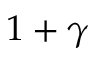Convert formula to latex. <formula><loc_0><loc_0><loc_500><loc_500>1 + \gamma</formula> 